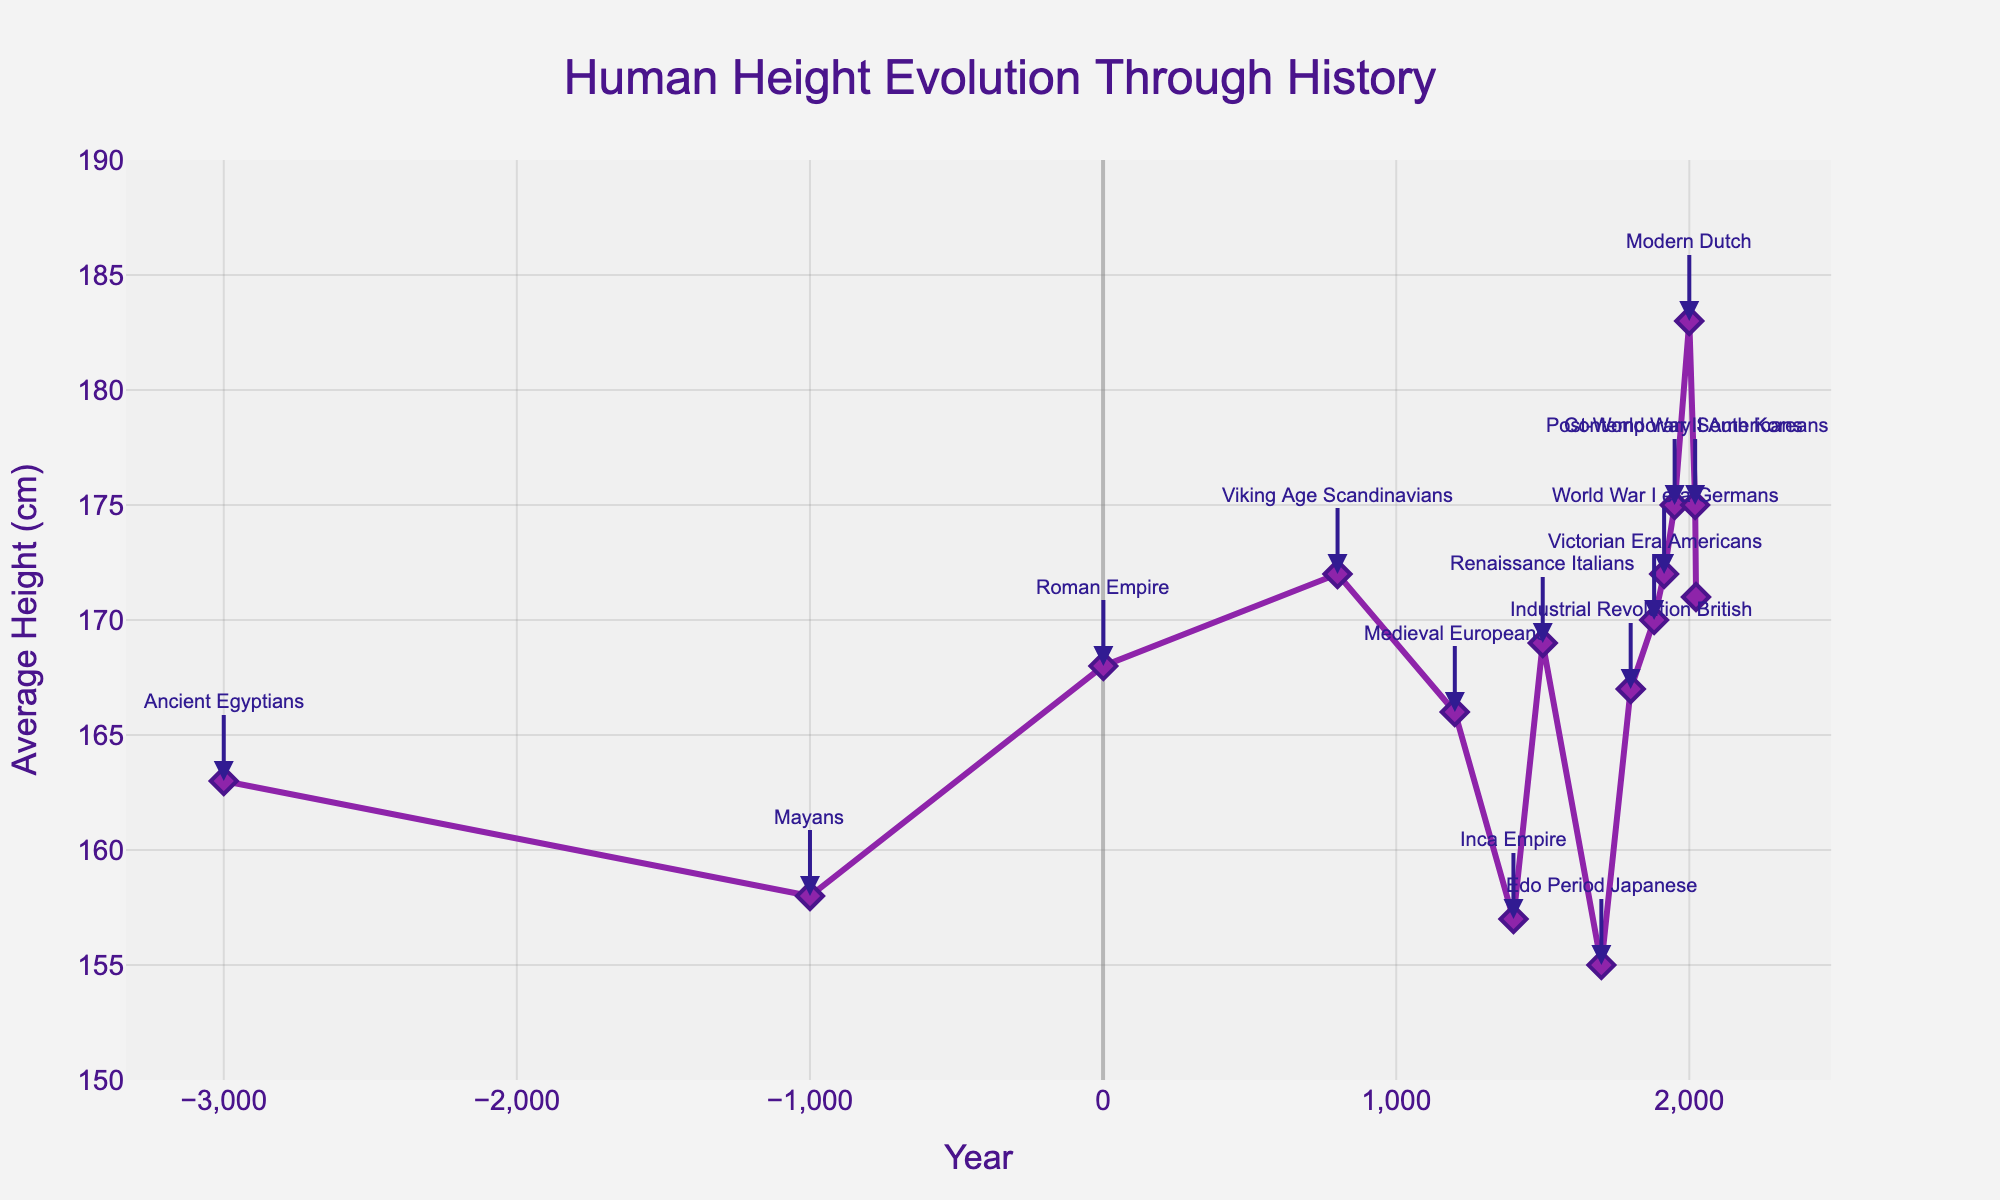What's the general trend in human height from ancient civilizations to modern times? By looking at the overall line, we can see that the average human height has generally increased from ancient times to modern times, with some fluctuations throughout history.
Answer: Increase Which civilization had the shortest average height according to the chart? By examining the y-values associated with each civilization, we see that the Edo Period Japanese had the shortest average height at 155 cm.
Answer: Edo Period Japanese How many times does the height decrease from one civilization to the next in the chart? Observing the line graph, the height decreases between Ancient Egyptians to Mayans, Viking Age Scandinavians to Medieval Europeans, Medieval Europeans to Inca Empire, among other points. There are 5 such decreases.
Answer: 5 Compare the heights of Renaissance Italians and Industrial Revolution British. Which was taller? By how much? Renaissance Italians had an average height of 169 cm, and the Industrial Revolution British had an average height of 167 cm. The Renaissance Italians were taller by 2 cm.
Answer: Renaissance Italians, 2 cm Does height increase or decrease more rapidly during the past 200 years compared to earlier periods? Comparing the slope of the line from 1800 onwards to earlier periods, we see a steeper increase in height, suggesting a more rapid increase in the past 200 years.
Answer: Increase more rapidly What was the trend in height around the time of the Inca Empire and Renaissance Italians? The average height for the Inca Empire was 157 cm, and during the Renaissance Italians, it increased to 169 cm, indicating an upward trend.
Answer: Upward trend Which two civilizations have the same average height on the chart? Both Viking Age Scandinavians and World War I era Germans have an average height of 172 cm.
Answer: Viking Age Scandinavians and World War I era Germans What height difference is observed between Ancient Egyptians and Modern Dutch? The Ancient Egyptians' average height was 163 cm, and Modern Dutch average height was 183 cm. The difference is 20 cm.
Answer: 20 cm Which civilization corresponds to the highest height peak on the chart? The highest peak on the chart corresponds to the Modern Dutch with an average height of 183 cm.
Answer: Modern Dutch Explain the height difference trend between the Industrial Revolution British and Post-World War II Americans. The Industrial Revolution British had an average height of 167 cm, while the Post-World War II Americans' average height increased to 175 cm, indicating an 8 cm increase.
Answer: 8 cm 